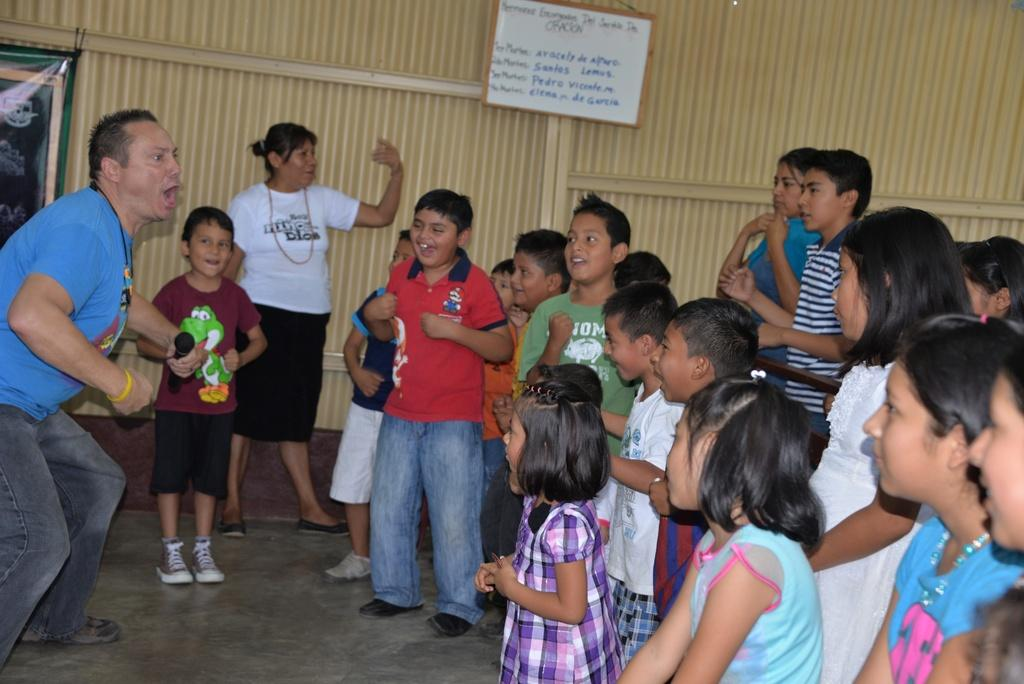How many people are in the image? There is a group of people in the image, but the exact number cannot be determined from the provided facts. What is on the wall in the image? There is a board on the wall in the image. What is on the left side of the image? There is a banner on the left side of the image. What type of beast can be seen making a quiet noise in the image? There is no beast or noise present in the image. 